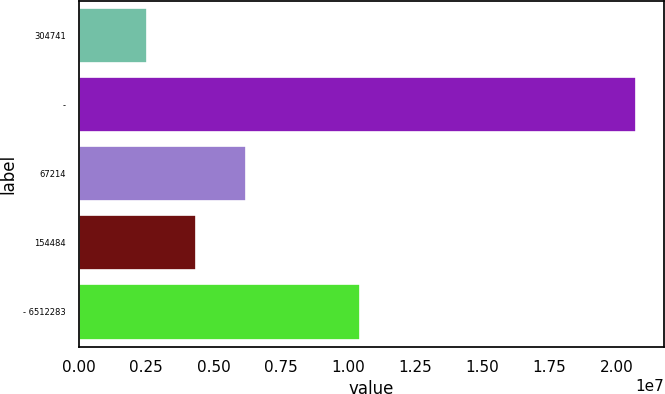<chart> <loc_0><loc_0><loc_500><loc_500><bar_chart><fcel>304741<fcel>-<fcel>67214<fcel>154484<fcel>- 6512283<nl><fcel>2.52678e+06<fcel>2.07299e+07<fcel>6.22117e+06<fcel>4.34709e+06<fcel>1.04698e+07<nl></chart> 